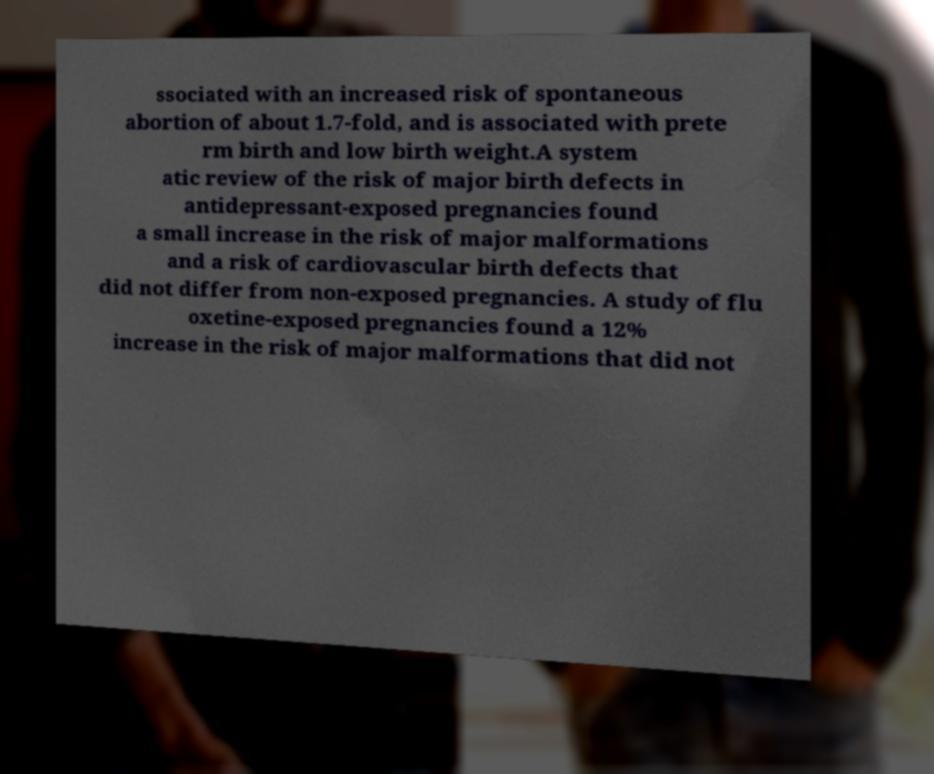Could you assist in decoding the text presented in this image and type it out clearly? ssociated with an increased risk of spontaneous abortion of about 1.7-fold, and is associated with prete rm birth and low birth weight.A system atic review of the risk of major birth defects in antidepressant-exposed pregnancies found a small increase in the risk of major malformations and a risk of cardiovascular birth defects that did not differ from non-exposed pregnancies. A study of flu oxetine-exposed pregnancies found a 12% increase in the risk of major malformations that did not 